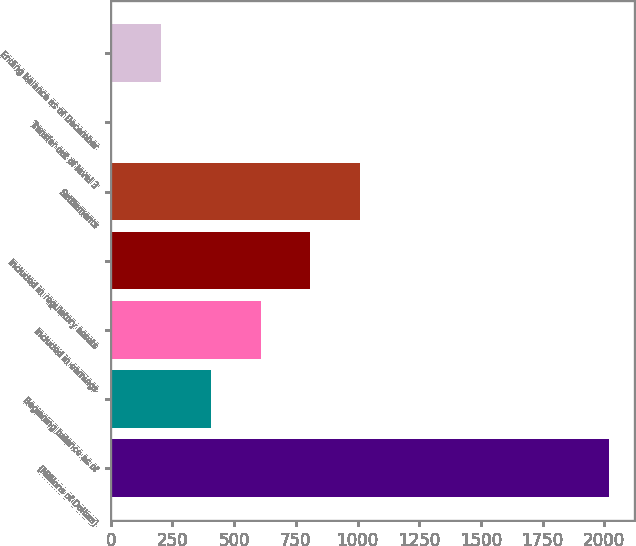Convert chart. <chart><loc_0><loc_0><loc_500><loc_500><bar_chart><fcel>(Millions of Dollars)<fcel>Beginning balance as of<fcel>Included in earnings<fcel>Included in regulatory assets<fcel>Settlements<fcel>Transfer out of level 3<fcel>Ending balance as of December<nl><fcel>2018<fcel>405.2<fcel>606.8<fcel>808.4<fcel>1010<fcel>2<fcel>203.6<nl></chart> 